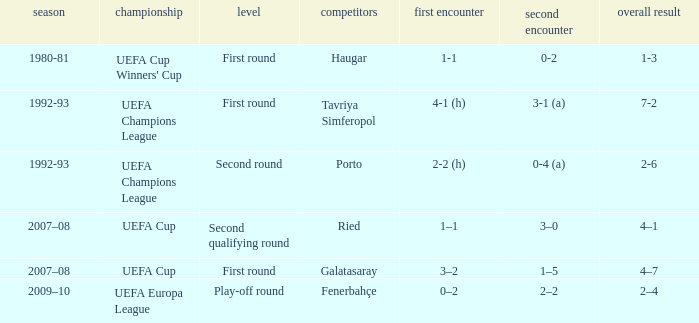 what's the aggregate where 1st leg is 3–2 4–7. I'm looking to parse the entire table for insights. Could you assist me with that? {'header': ['season', 'championship', 'level', 'competitors', 'first encounter', 'second encounter', 'overall result'], 'rows': [['1980-81', "UEFA Cup Winners' Cup", 'First round', 'Haugar', '1-1', '0-2', '1-3'], ['1992-93', 'UEFA Champions League', 'First round', 'Tavriya Simferopol', '4-1 (h)', '3-1 (a)', '7-2'], ['1992-93', 'UEFA Champions League', 'Second round', 'Porto', '2-2 (h)', '0-4 (a)', '2-6'], ['2007–08', 'UEFA Cup', 'Second qualifying round', 'Ried', '1–1', '3–0', '4–1'], ['2007–08', 'UEFA Cup', 'First round', 'Galatasaray', '3–2', '1–5', '4–7'], ['2009–10', 'UEFA Europa League', 'Play-off round', 'Fenerbahçe', '0–2', '2–2', '2–4']]} 